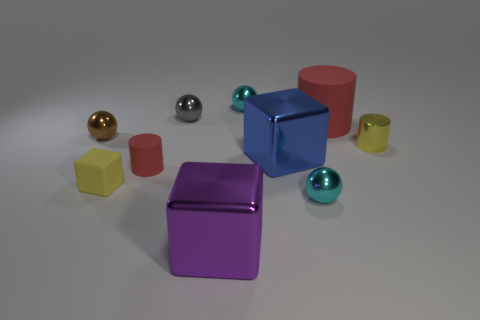Subtract all green balls. Subtract all blue cubes. How many balls are left? 4 Subtract all cubes. How many objects are left? 7 Subtract 0 cyan blocks. How many objects are left? 10 Subtract all cyan metallic spheres. Subtract all tiny gray spheres. How many objects are left? 7 Add 6 yellow cylinders. How many yellow cylinders are left? 7 Add 6 big cylinders. How many big cylinders exist? 7 